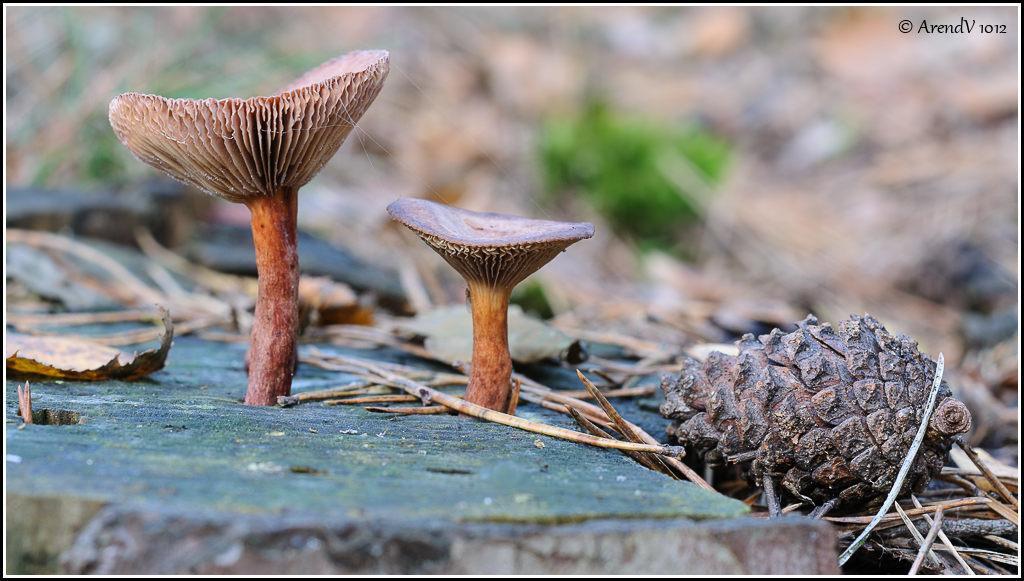Can you describe this image briefly? In this image there are mushrooms, dried sticks, plants. There is a dried pineapple fruit and the background of the image is blur. There is some text at the top of the image. 